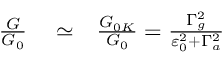Convert formula to latex. <formula><loc_0><loc_0><loc_500><loc_500>\begin{array} { r l r } { \frac { G } { G _ { 0 } } } & \simeq } & { \frac { G _ { 0 K } } { G _ { 0 } } = \frac { \Gamma _ { g } ^ { 2 } } { \varepsilon _ { 0 } ^ { 2 } + \Gamma _ { a } ^ { 2 } } } \end{array}</formula> 